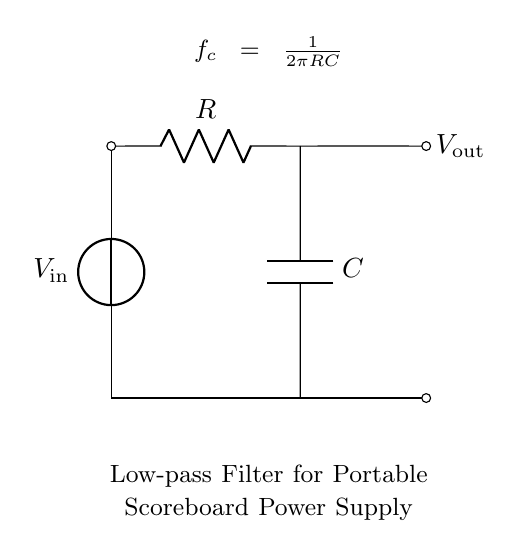What type of filter is depicted in this circuit? The circuit is labeled as a low-pass filter, which allows low-frequency signals to pass through while attenuating higher-frequency signals.
Answer: Low-pass filter What are the two main components of the circuit? The components present in the diagram are a resistor and a capacitor. The resistance and capacitance are crucial for determining the cutoff frequency of the filter.
Answer: Resistor and capacitor What is the function of the output voltage in this circuit? The output voltage provides the smoothed power supply voltage to the portable scoreboard display, reflecting the filtered input voltage after it has passed through the low-pass filter components.
Answer: Smoothing power supply What is the cutoff frequency formula shown in the circuit? The circuit diagram provides the formula for the cutoff frequency, which is calculated using the resistance and capacitance values in the circuit. The formula is divided into components: the factor of two pi and the multiplication of R and C.
Answer: 1 over 2 pi RC How does increasing the capacitance affect the cutoff frequency? Increasing the capacitance in the circuit will decrease the cutoff frequency, which means that the circuit will allow even lower frequencies to pass through and more effectively smooth out fluctuations in the input voltage.
Answer: Decreases cutoff frequency What happens if you remove the resistor from the circuit? Removing the resistor would alter the behavior of the low-pass filter, possibly resulting in an impedance mismatch that could lead to insufficient filtering of the input voltage, as there would be no resistance to establish an RC time constant.
Answer: Insufficient filtering 